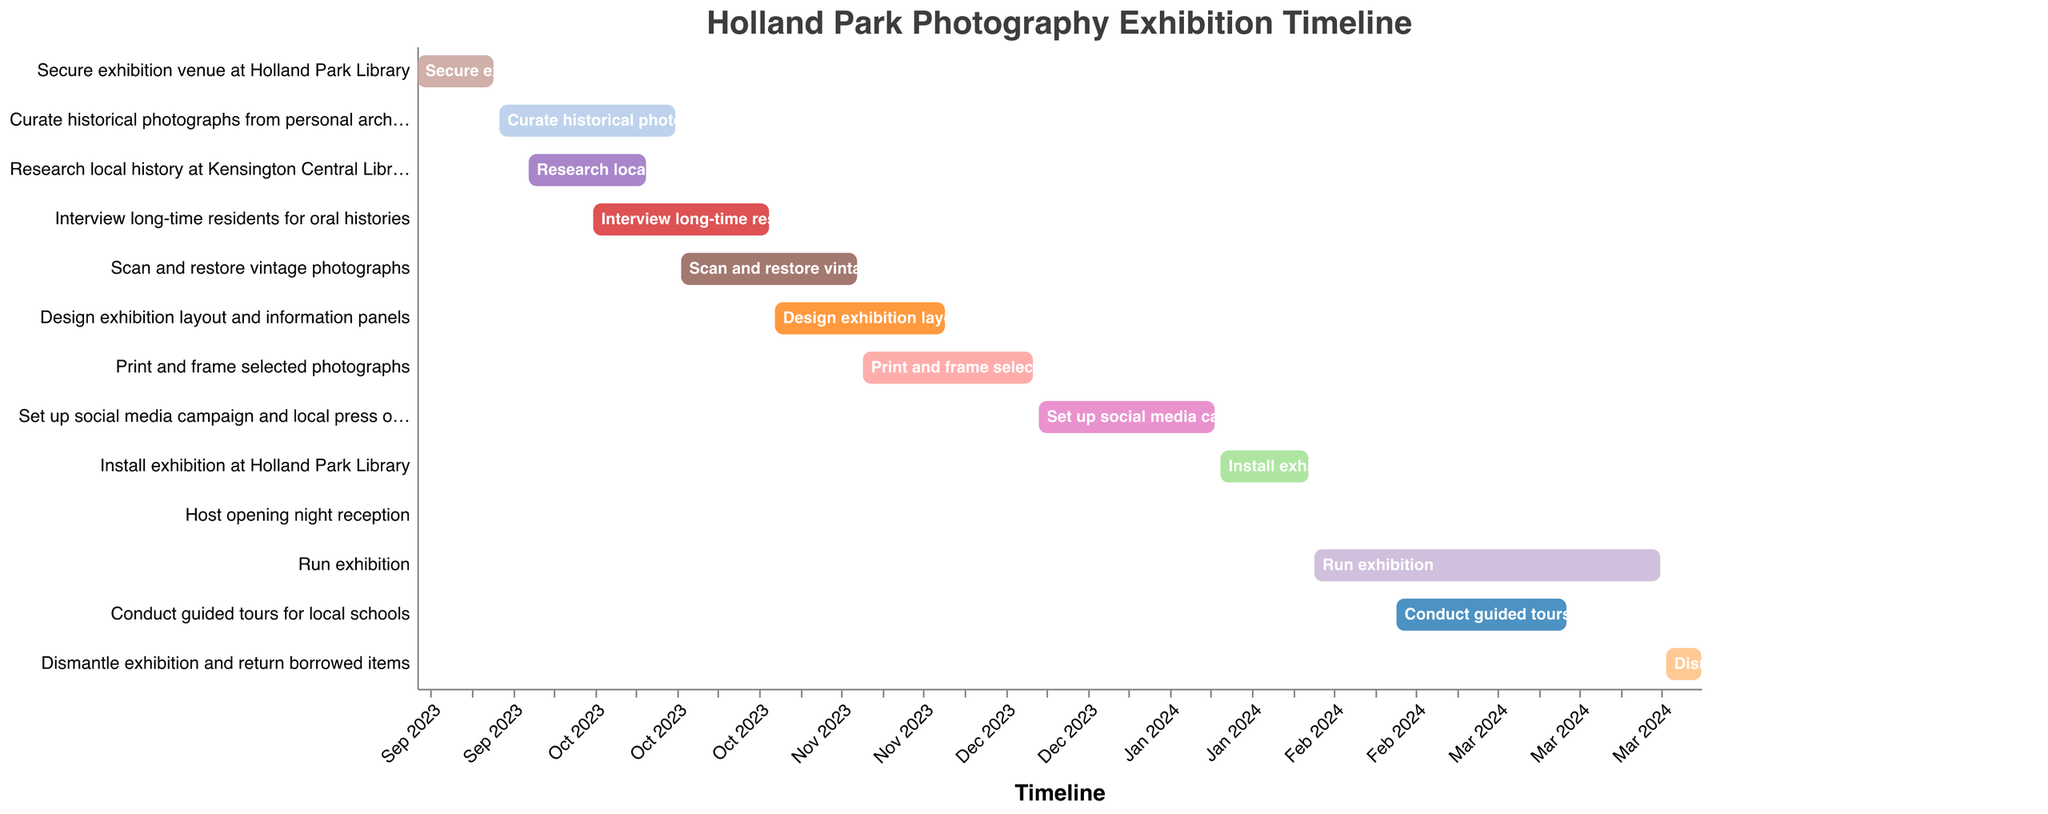What is the title of the Gantt chart? The title is the main text that is usually displayed at the top of the Gantt chart. Just look at the text at the top center of the chart.
Answer: Holland Park Photography Exhibition Timeline When does the task "Curate historical photographs from personal archive" start and end? Check the y-axis for the specific task "Curate historical photographs from personal archive", then follow the horizontal bars to find its start and end dates on the x-axis.
Answer: 2023-09-15 to 2023-10-15 How long does the "Scan and restore vintage photographs" task take? Find the task "Scan and restore vintage photographs" on the y-axis, then look at its start and end dates. Calculate the difference between the end date and the start date.
Answer: 30 days Which tasks are overlapping with "Interview long-time residents for oral histories"? Find the time range for "Interview long-time residents for oral histories" and see which other tasks have bars that intersect this time range.
Answer: Scan and restore vintage photographs, Curate historical photographs from personal archive Which task has the shortest duration? Look for the bars on the chart and measure their lengths. The shortest bar indicates the task with the shortest duration.
Answer: Host opening night reception What is the total duration of tasks that start in October 2023? Identify tasks that start in October 2023. Sum up their durations by checking their start and end dates. Curate historical photographs from personal archive (1 day overlaps into October).
Answer: 51 days (1 month and 21 days) What tasks are scheduled to start after December 2023? Look for the tasks whose start dates are beyond December 2023 on the x-axis.
Answer: Set up social media campaign and local press outreach, Install exhibition at Holland Park Library, Host opening night reception, Run exhibition, Conduct guided tours for local schools, Dismantle exhibition and return borrowed items Compare the durations of "Print and frame selected photographs" and "Design exhibition layout and information panels". Which one is longer? Measure the lengths of the bars for both tasks. Compare the start and end dates to determine which task spans a longer period.
Answer: Print and frame selected photographs Which task continues for the longest period into 2024? Identify tasks that extend into 2024 and compare the lengths of their bars.
Answer: Run exhibition 